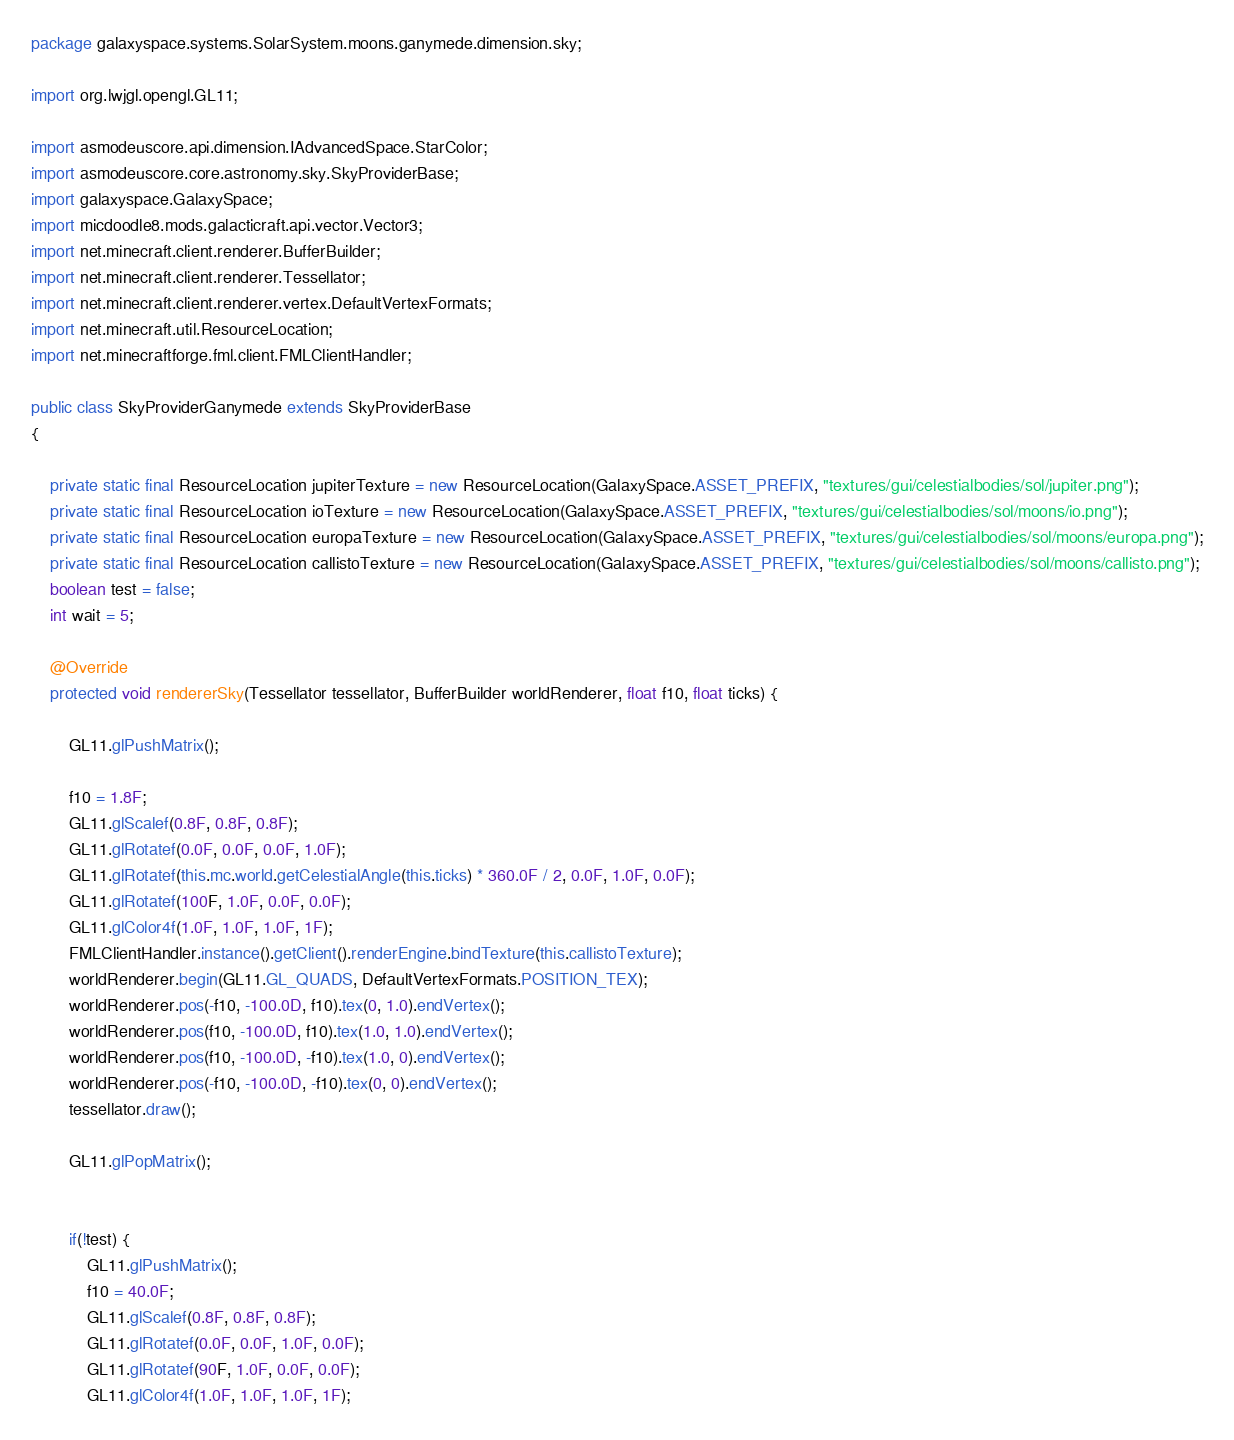<code> <loc_0><loc_0><loc_500><loc_500><_Java_>package galaxyspace.systems.SolarSystem.moons.ganymede.dimension.sky;

import org.lwjgl.opengl.GL11;

import asmodeuscore.api.dimension.IAdvancedSpace.StarColor;
import asmodeuscore.core.astronomy.sky.SkyProviderBase;
import galaxyspace.GalaxySpace;
import micdoodle8.mods.galacticraft.api.vector.Vector3;
import net.minecraft.client.renderer.BufferBuilder;
import net.minecraft.client.renderer.Tessellator;
import net.minecraft.client.renderer.vertex.DefaultVertexFormats;
import net.minecraft.util.ResourceLocation;
import net.minecraftforge.fml.client.FMLClientHandler;

public class SkyProviderGanymede extends SkyProviderBase
{

	private static final ResourceLocation jupiterTexture = new ResourceLocation(GalaxySpace.ASSET_PREFIX, "textures/gui/celestialbodies/sol/jupiter.png");
	private static final ResourceLocation ioTexture = new ResourceLocation(GalaxySpace.ASSET_PREFIX, "textures/gui/celestialbodies/sol/moons/io.png");
    private static final ResourceLocation europaTexture = new ResourceLocation(GalaxySpace.ASSET_PREFIX, "textures/gui/celestialbodies/sol/moons/europa.png");
    private static final ResourceLocation callistoTexture = new ResourceLocation(GalaxySpace.ASSET_PREFIX, "textures/gui/celestialbodies/sol/moons/callisto.png");
    boolean test = false;
    int wait = 5;
    
	@Override
	protected void rendererSky(Tessellator tessellator, BufferBuilder worldRenderer, float f10, float ticks) {
		
		GL11.glPushMatrix();
		
		f10 = 1.8F;
		GL11.glScalef(0.8F, 0.8F, 0.8F);
		GL11.glRotatef(0.0F, 0.0F, 0.0F, 1.0F);		
		GL11.glRotatef(this.mc.world.getCelestialAngle(this.ticks) * 360.0F / 2, 0.0F, 1.0F, 0.0F);
		GL11.glRotatef(100F, 1.0F, 0.0F, 0.0F);
		GL11.glColor4f(1.0F, 1.0F, 1.0F, 1F);
		FMLClientHandler.instance().getClient().renderEngine.bindTexture(this.callistoTexture);
		worldRenderer.begin(GL11.GL_QUADS, DefaultVertexFormats.POSITION_TEX);
		worldRenderer.pos(-f10, -100.0D, f10).tex(0, 1.0).endVertex();
		worldRenderer.pos(f10, -100.0D, f10).tex(1.0, 1.0).endVertex();
		worldRenderer.pos(f10, -100.0D, -f10).tex(1.0, 0).endVertex();
		worldRenderer.pos(-f10, -100.0D, -f10).tex(0, 0).endVertex();
		tessellator.draw();        

        GL11.glPopMatrix();
        

        if(!test) {
        	GL11.glPushMatrix();
			f10 = 40.0F;
			GL11.glScalef(0.8F, 0.8F, 0.8F);
			GL11.glRotatef(0.0F, 0.0F, 1.0F, 0.0F);
			GL11.glRotatef(90F, 1.0F, 0.0F, 0.0F);
			GL11.glColor4f(1.0F, 1.0F, 1.0F, 1F);</code> 